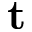Convert formula to latex. <formula><loc_0><loc_0><loc_500><loc_500>t</formula> 